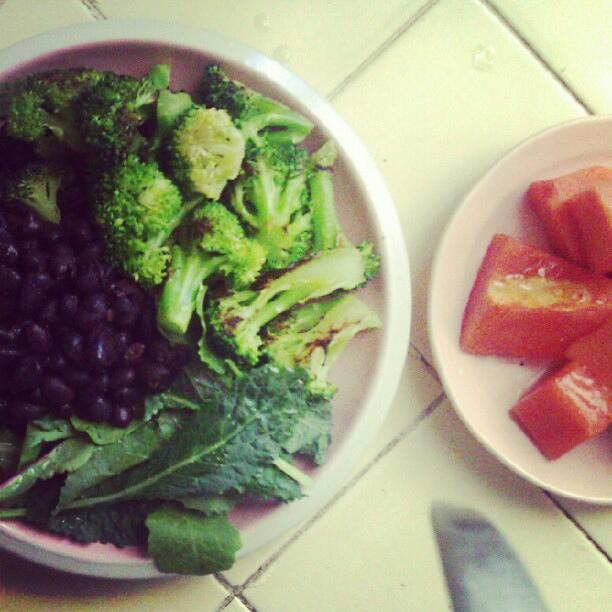Which item is likely most crispy?

Choices:
A) black
B) lighter green
C) red
D) dark green lighter green 